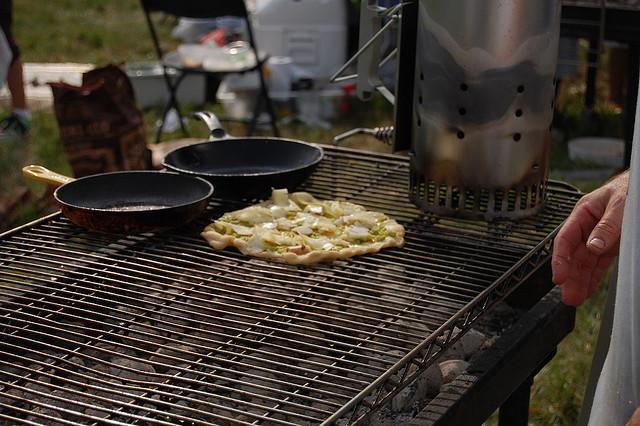Where is the item being grilled normally prepared?
Choose the correct response and explain in the format: 'Answer: answer
Rationale: rationale.'
Options: Grill, griddle, sauce pot, oven. Answer: oven.
Rationale: A pizza is on a grill. pizzas are traditionally cooked in ovens. 